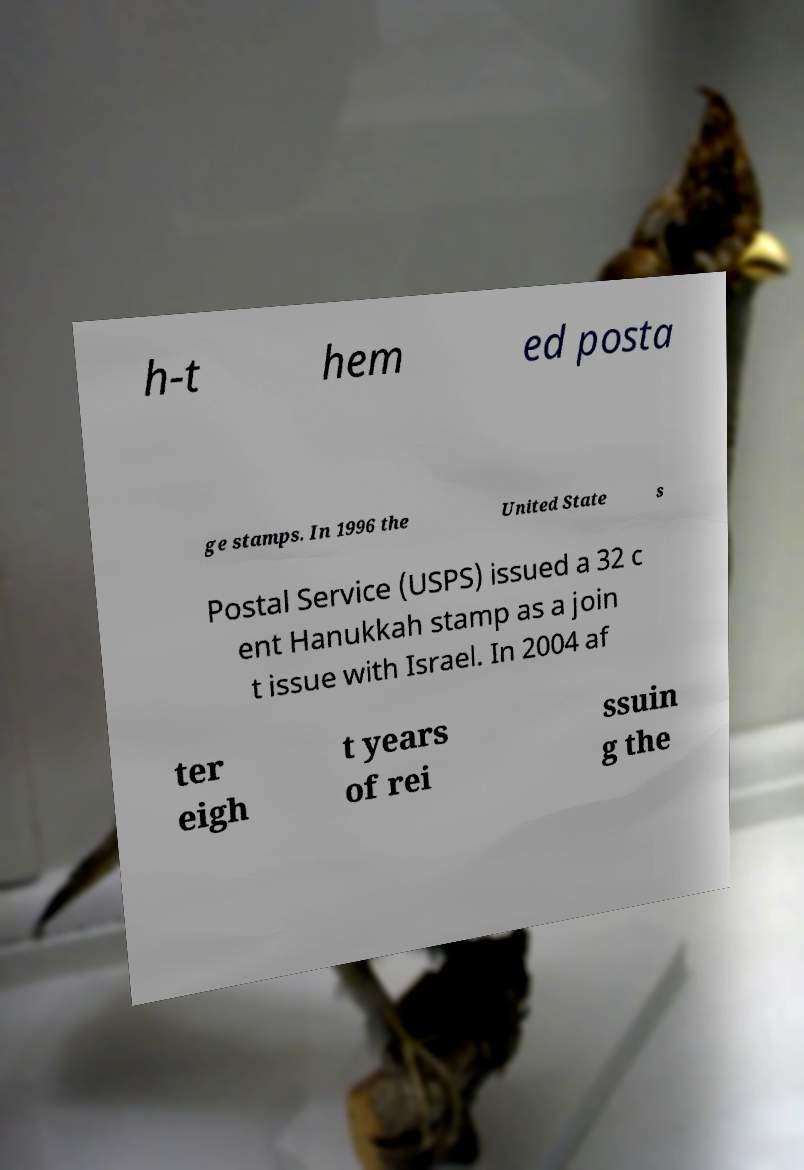For documentation purposes, I need the text within this image transcribed. Could you provide that? h-t hem ed posta ge stamps. In 1996 the United State s Postal Service (USPS) issued a 32 c ent Hanukkah stamp as a join t issue with Israel. In 2004 af ter eigh t years of rei ssuin g the 